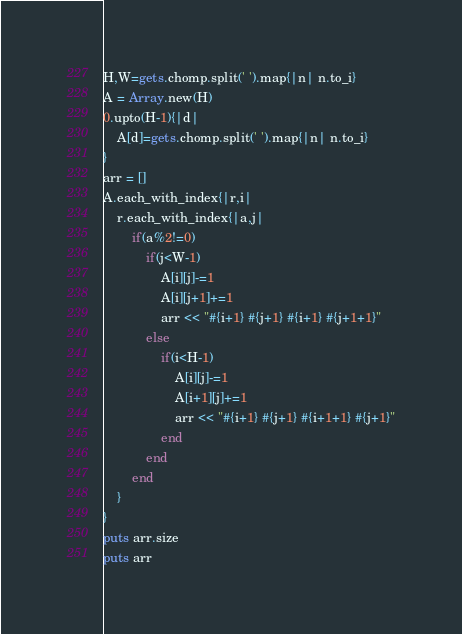<code> <loc_0><loc_0><loc_500><loc_500><_Ruby_>H,W=gets.chomp.split(' ').map{|n| n.to_i}
A = Array.new(H)
0.upto(H-1){|d|
	A[d]=gets.chomp.split(' ').map{|n| n.to_i}
}
arr = []
A.each_with_index{|r,i|
	r.each_with_index{|a,j|
		if(a%2!=0)
			if(j<W-1)
				A[i][j]-=1
				A[i][j+1]+=1
				arr << "#{i+1} #{j+1} #{i+1} #{j+1+1}"
			else
				if(i<H-1)
					A[i][j]-=1
					A[i+1][j]+=1
					arr << "#{i+1} #{j+1} #{i+1+1} #{j+1}"
				end
			end
		end
	}
}
puts arr.size
puts arr
</code> 